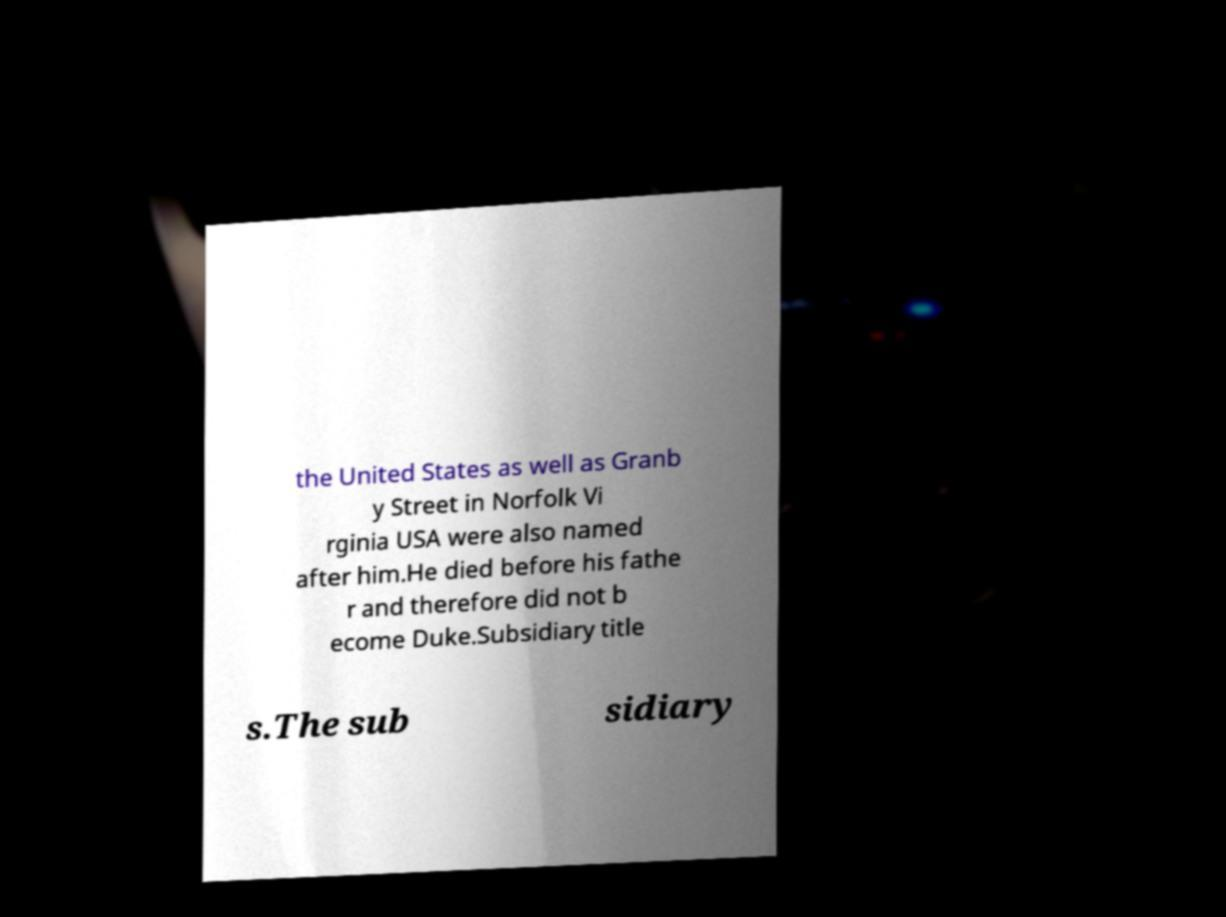Could you assist in decoding the text presented in this image and type it out clearly? the United States as well as Granb y Street in Norfolk Vi rginia USA were also named after him.He died before his fathe r and therefore did not b ecome Duke.Subsidiary title s.The sub sidiary 